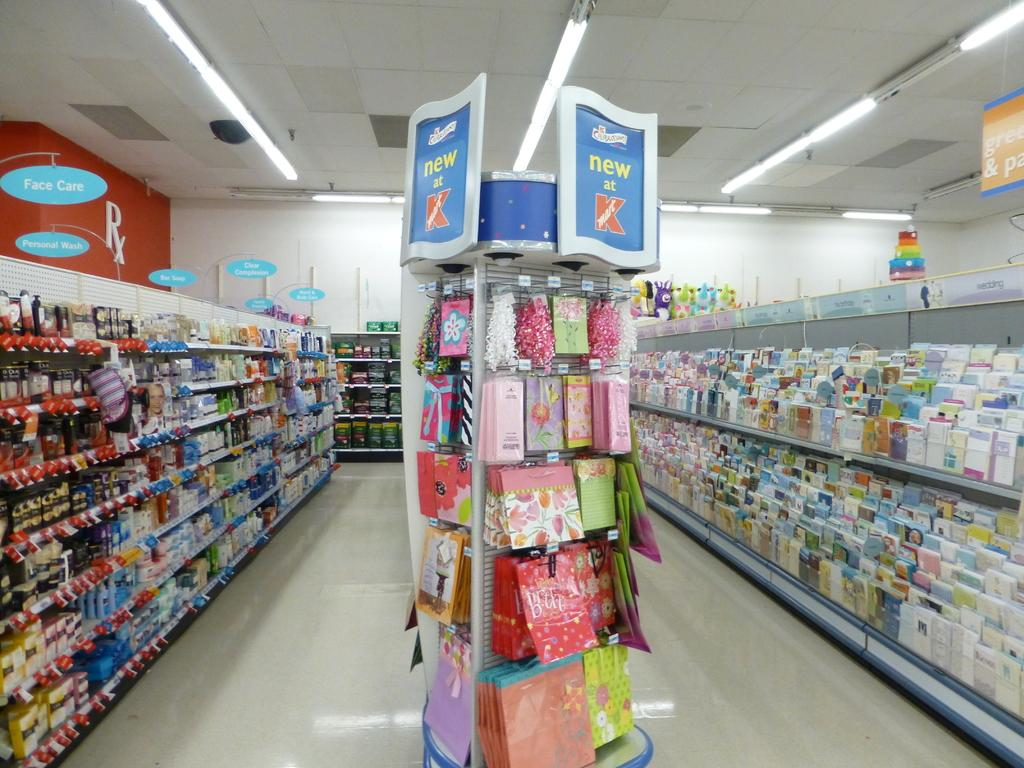<image>
Present a compact description of the photo's key features. A display rack is shown in the aisle of a Kmart store. 